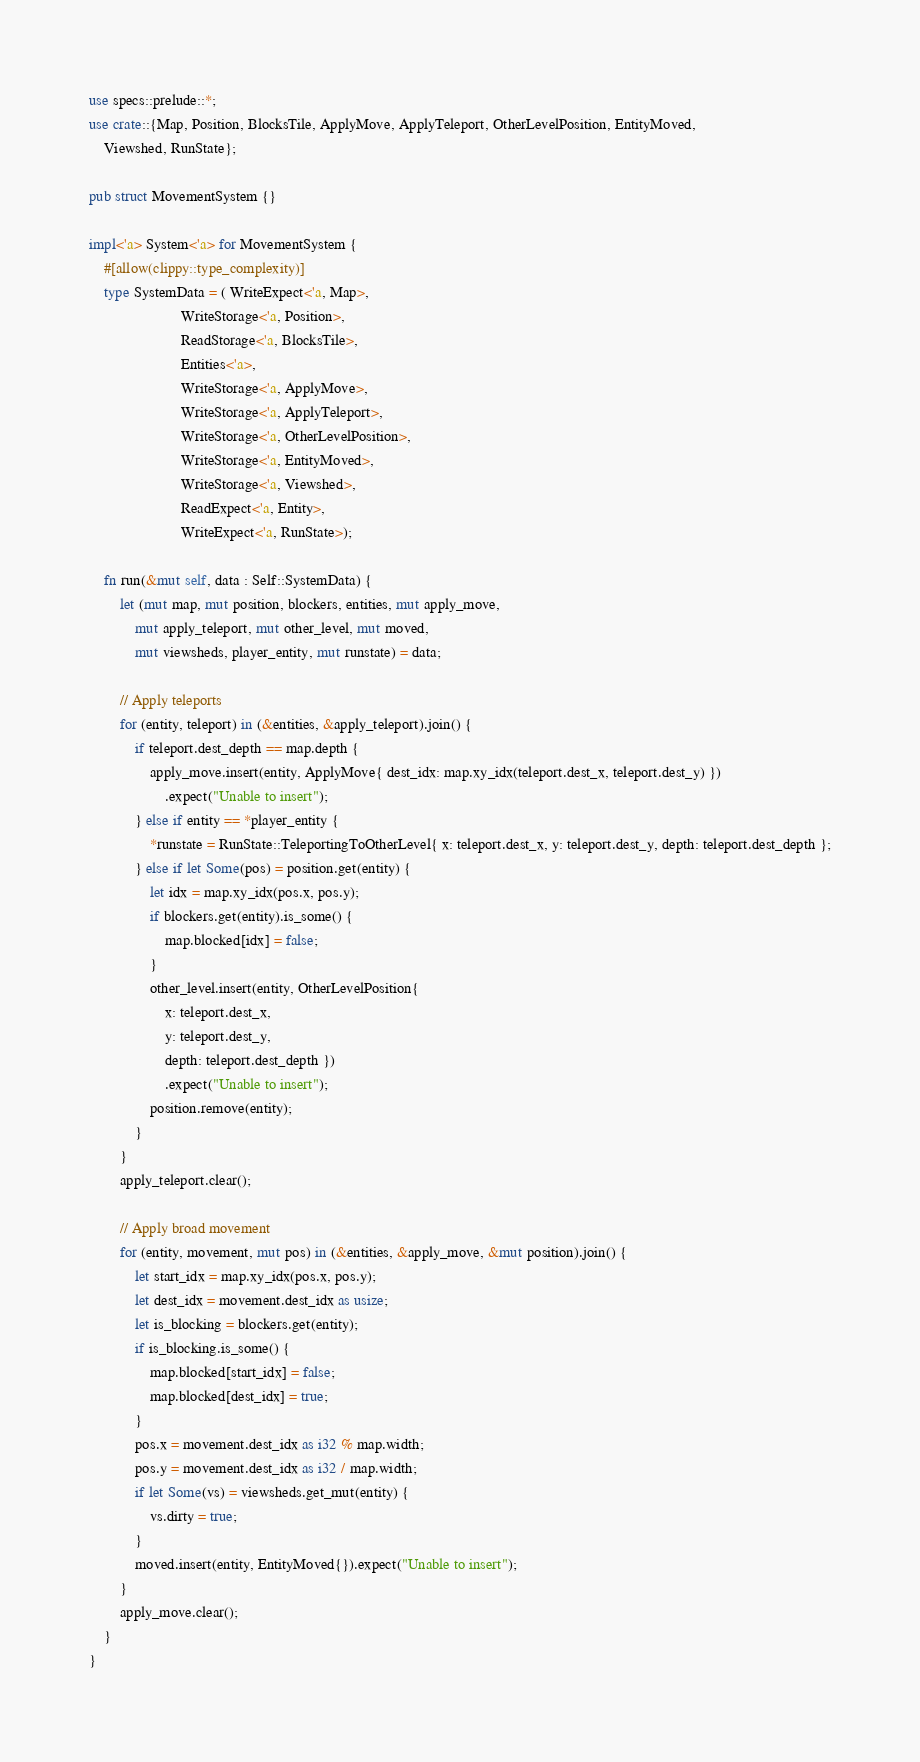<code> <loc_0><loc_0><loc_500><loc_500><_Rust_>use specs::prelude::*;
use crate::{Map, Position, BlocksTile, ApplyMove, ApplyTeleport, OtherLevelPosition, EntityMoved,
    Viewshed, RunState};

pub struct MovementSystem {}

impl<'a> System<'a> for MovementSystem {
    #[allow(clippy::type_complexity)]
    type SystemData = ( WriteExpect<'a, Map>,
                        WriteStorage<'a, Position>,
                        ReadStorage<'a, BlocksTile>,
                        Entities<'a>,
                        WriteStorage<'a, ApplyMove>,
                        WriteStorage<'a, ApplyTeleport>,
                        WriteStorage<'a, OtherLevelPosition>,
                        WriteStorage<'a, EntityMoved>,
                        WriteStorage<'a, Viewshed>,
                        ReadExpect<'a, Entity>,
                        WriteExpect<'a, RunState>);

    fn run(&mut self, data : Self::SystemData) {
        let (mut map, mut position, blockers, entities, mut apply_move,
            mut apply_teleport, mut other_level, mut moved,
            mut viewsheds, player_entity, mut runstate) = data;

        // Apply teleports
        for (entity, teleport) in (&entities, &apply_teleport).join() {
            if teleport.dest_depth == map.depth {
                apply_move.insert(entity, ApplyMove{ dest_idx: map.xy_idx(teleport.dest_x, teleport.dest_y) })
                    .expect("Unable to insert");
            } else if entity == *player_entity {
                *runstate = RunState::TeleportingToOtherLevel{ x: teleport.dest_x, y: teleport.dest_y, depth: teleport.dest_depth };
            } else if let Some(pos) = position.get(entity) {
                let idx = map.xy_idx(pos.x, pos.y);
                if blockers.get(entity).is_some() {
                    map.blocked[idx] = false;
                }
                other_level.insert(entity, OtherLevelPosition{
                    x: teleport.dest_x,
                    y: teleport.dest_y,
                    depth: teleport.dest_depth })
                    .expect("Unable to insert");
                position.remove(entity);
            }
        }
        apply_teleport.clear();

        // Apply broad movement
        for (entity, movement, mut pos) in (&entities, &apply_move, &mut position).join() {
            let start_idx = map.xy_idx(pos.x, pos.y);
            let dest_idx = movement.dest_idx as usize;
            let is_blocking = blockers.get(entity);
            if is_blocking.is_some() {
                map.blocked[start_idx] = false;
                map.blocked[dest_idx] = true;
            }
            pos.x = movement.dest_idx as i32 % map.width;
            pos.y = movement.dest_idx as i32 / map.width;
            if let Some(vs) = viewsheds.get_mut(entity) {
                vs.dirty = true;
            }
            moved.insert(entity, EntityMoved{}).expect("Unable to insert");
        }
        apply_move.clear();
    }
}
</code> 